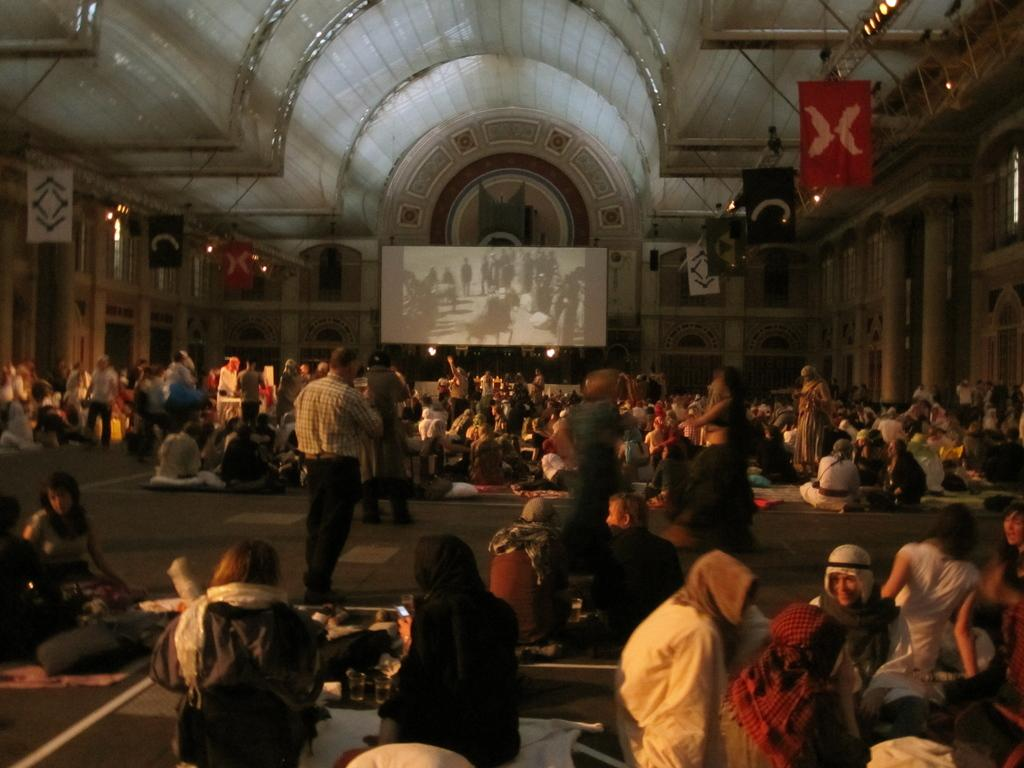What are the people in the image doing? Some people are standing, and others are sitting in the image. What type of structure can be seen in the image? There is a building in the image. Can you see a tiger in the image? There is no tiger present in the image. 